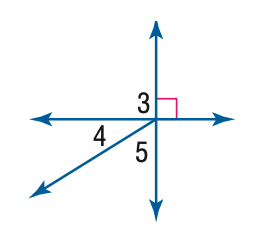Answer the mathemtical geometry problem and directly provide the correct option letter.
Question: m \angle 4 = 32. Find the measure of \angle 3.
Choices: A: 32 B: 58 C: 90 D: 180 C 